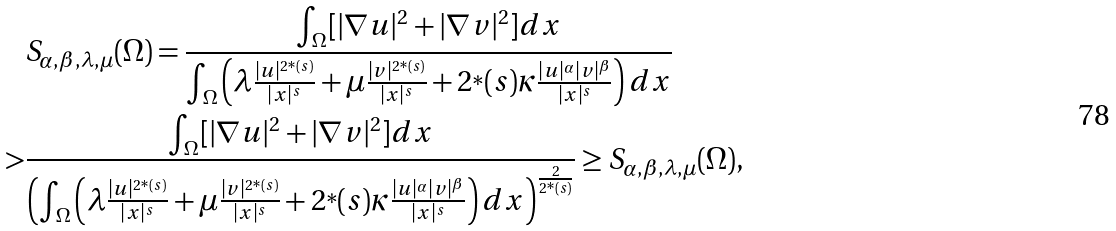<formula> <loc_0><loc_0><loc_500><loc_500>& S _ { \alpha , \beta , \lambda , \mu } ( \Omega ) = \frac { \int _ { \Omega } [ | \nabla u | ^ { 2 } + | \nabla v | ^ { 2 } ] d x } { \int _ { \Omega } \left ( \lambda \frac { | u | ^ { 2 ^ { * } ( s ) } } { | x | ^ { s } } + \mu \frac { | v | ^ { 2 ^ { * } ( s ) } } { | x | ^ { s } } + 2 ^ { * } ( s ) \kappa \frac { | u | ^ { \alpha } | v | ^ { \beta } } { | x | ^ { s } } \right ) d x } \\ > & \frac { \int _ { \Omega } [ | \nabla u | ^ { 2 } + | \nabla v | ^ { 2 } ] d x } { \left ( \int _ { \Omega } \left ( \lambda \frac { | u | ^ { 2 ^ { * } ( s ) } } { | x | ^ { s } } + \mu \frac { | v | ^ { 2 ^ { * } ( s ) } } { | x | ^ { s } } + 2 ^ { * } ( s ) \kappa \frac { | u | ^ { \alpha } | v | ^ { \beta } } { | x | ^ { s } } \right ) d x \right ) ^ { \frac { 2 } { 2 ^ { * } ( s ) } } } \geq S _ { \alpha , \beta , \lambda , \mu } ( \Omega ) ,</formula> 